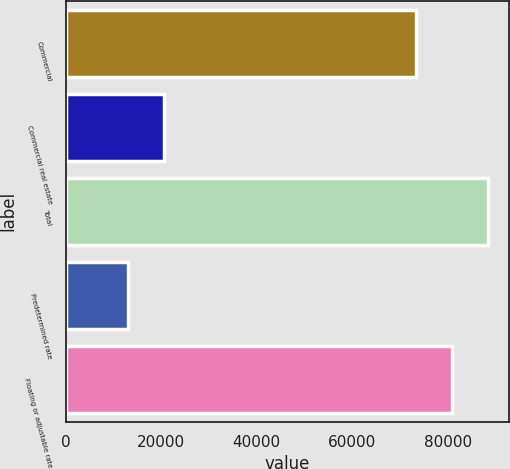Convert chart. <chart><loc_0><loc_0><loc_500><loc_500><bar_chart><fcel>Commercial<fcel>Commercial real estate<fcel>Total<fcel>Predetermined rate<fcel>Floating or adjustable rate<nl><fcel>73299<fcel>20561.6<fcel>88294.2<fcel>13064<fcel>80796.6<nl></chart> 